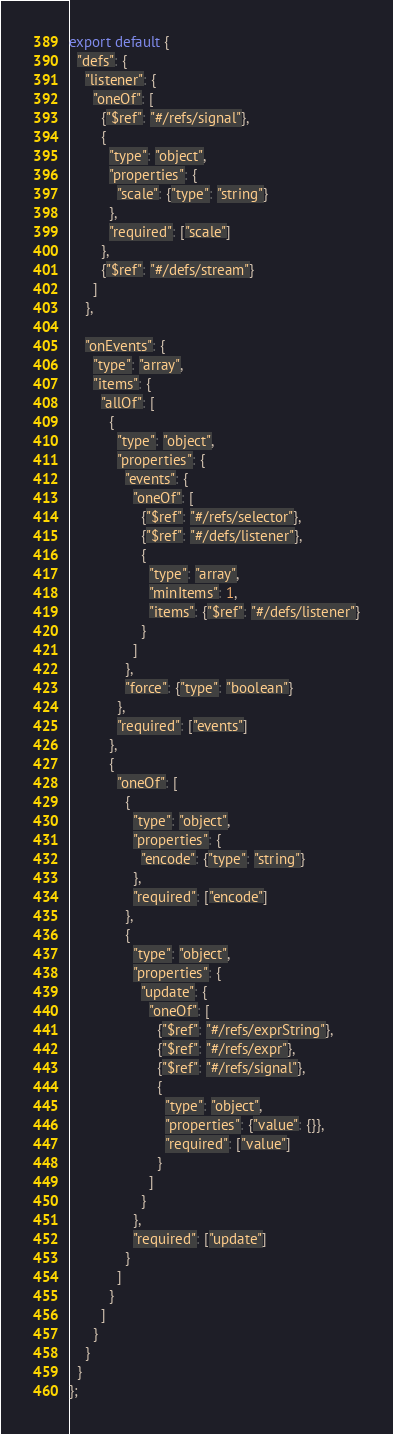<code> <loc_0><loc_0><loc_500><loc_500><_JavaScript_>export default {
  "defs": {
    "listener": {
      "oneOf": [
        {"$ref": "#/refs/signal"},
        {
          "type": "object",
          "properties": {
            "scale": {"type": "string"}
          },
          "required": ["scale"]
        },
        {"$ref": "#/defs/stream"}
      ]
    },

    "onEvents": {
      "type": "array",
      "items": {
        "allOf": [
          {
            "type": "object",
            "properties": {
              "events": {
                "oneOf": [
                  {"$ref": "#/refs/selector"},
                  {"$ref": "#/defs/listener"},
                  {
                    "type": "array",
                    "minItems": 1,
                    "items": {"$ref": "#/defs/listener"}
                  }
                ]
              },
              "force": {"type": "boolean"}
            },
            "required": ["events"]
          },
          {
            "oneOf": [
              {
                "type": "object",
                "properties": {
                  "encode": {"type": "string"}
                },
                "required": ["encode"]
              },
              {
                "type": "object",
                "properties": {
                  "update": {
                    "oneOf": [
                      {"$ref": "#/refs/exprString"},
                      {"$ref": "#/refs/expr"},
                      {"$ref": "#/refs/signal"},
                      {
                        "type": "object",
                        "properties": {"value": {}},
                        "required": ["value"]
                      }
                    ]
                  }
                },
                "required": ["update"]
              }
            ]
          }
        ]
      }
    }
  }
};
</code> 